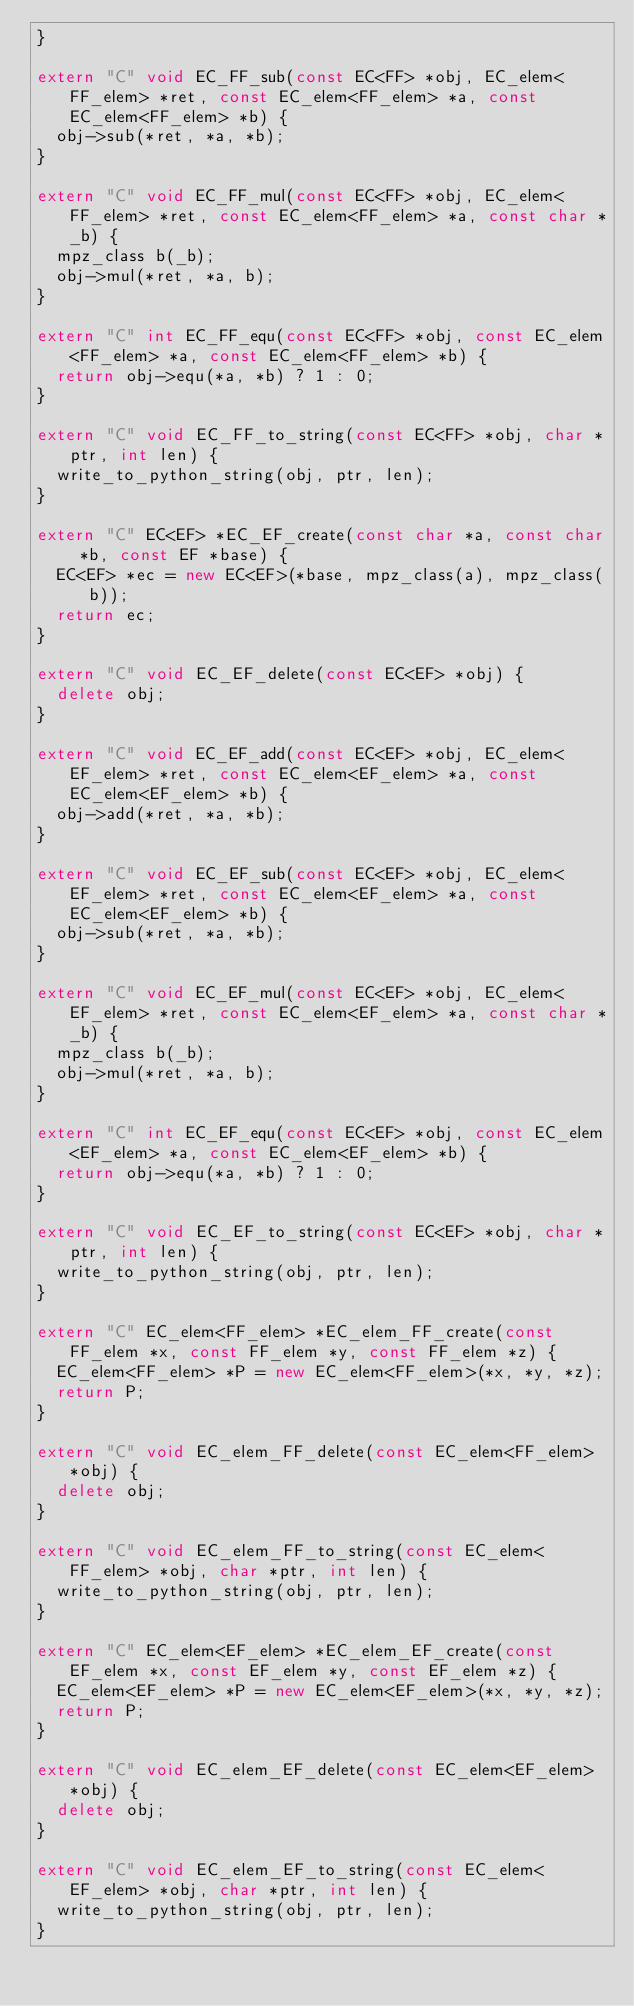<code> <loc_0><loc_0><loc_500><loc_500><_C++_>}

extern "C" void EC_FF_sub(const EC<FF> *obj, EC_elem<FF_elem> *ret, const EC_elem<FF_elem> *a, const EC_elem<FF_elem> *b) {
  obj->sub(*ret, *a, *b);
}

extern "C" void EC_FF_mul(const EC<FF> *obj, EC_elem<FF_elem> *ret, const EC_elem<FF_elem> *a, const char *_b) {
  mpz_class b(_b);
  obj->mul(*ret, *a, b);
}

extern "C" int EC_FF_equ(const EC<FF> *obj, const EC_elem<FF_elem> *a, const EC_elem<FF_elem> *b) {
  return obj->equ(*a, *b) ? 1 : 0;
}

extern "C" void EC_FF_to_string(const EC<FF> *obj, char *ptr, int len) {
  write_to_python_string(obj, ptr, len);
}

extern "C" EC<EF> *EC_EF_create(const char *a, const char *b, const EF *base) {
  EC<EF> *ec = new EC<EF>(*base, mpz_class(a), mpz_class(b));
  return ec;
}

extern "C" void EC_EF_delete(const EC<EF> *obj) {
  delete obj;
}

extern "C" void EC_EF_add(const EC<EF> *obj, EC_elem<EF_elem> *ret, const EC_elem<EF_elem> *a, const EC_elem<EF_elem> *b) {
  obj->add(*ret, *a, *b);
}

extern "C" void EC_EF_sub(const EC<EF> *obj, EC_elem<EF_elem> *ret, const EC_elem<EF_elem> *a, const EC_elem<EF_elem> *b) {
  obj->sub(*ret, *a, *b);
}

extern "C" void EC_EF_mul(const EC<EF> *obj, EC_elem<EF_elem> *ret, const EC_elem<EF_elem> *a, const char *_b) {
  mpz_class b(_b);
  obj->mul(*ret, *a, b);
}

extern "C" int EC_EF_equ(const EC<EF> *obj, const EC_elem<EF_elem> *a, const EC_elem<EF_elem> *b) {
  return obj->equ(*a, *b) ? 1 : 0;
}

extern "C" void EC_EF_to_string(const EC<EF> *obj, char *ptr, int len) {
  write_to_python_string(obj, ptr, len);
}

extern "C" EC_elem<FF_elem> *EC_elem_FF_create(const FF_elem *x, const FF_elem *y, const FF_elem *z) {
  EC_elem<FF_elem> *P = new EC_elem<FF_elem>(*x, *y, *z);
  return P;
}

extern "C" void EC_elem_FF_delete(const EC_elem<FF_elem> *obj) {
  delete obj;
}

extern "C" void EC_elem_FF_to_string(const EC_elem<FF_elem> *obj, char *ptr, int len) {
  write_to_python_string(obj, ptr, len);
}

extern "C" EC_elem<EF_elem> *EC_elem_EF_create(const EF_elem *x, const EF_elem *y, const EF_elem *z) {
  EC_elem<EF_elem> *P = new EC_elem<EF_elem>(*x, *y, *z);
  return P;
}

extern "C" void EC_elem_EF_delete(const EC_elem<EF_elem> *obj) {
  delete obj;
}

extern "C" void EC_elem_EF_to_string(const EC_elem<EF_elem> *obj, char *ptr, int len) {
  write_to_python_string(obj, ptr, len);
}
</code> 